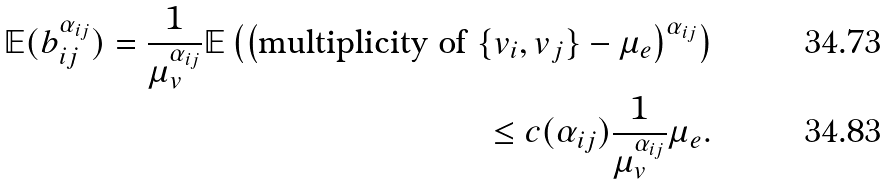Convert formula to latex. <formula><loc_0><loc_0><loc_500><loc_500>\mathbb { E } ( b _ { i j } ^ { \alpha _ { i j } } ) = \frac { 1 } { \mu _ { v } ^ { \alpha _ { i j } } } \mathbb { E } \left ( \left ( \text {multiplicity of } \{ v _ { i } , v _ { j } \} - \mu _ { e } \right ) ^ { \alpha _ { i j } } \right ) \\ \leq c ( \alpha _ { i j } ) \frac { 1 } { \mu _ { v } ^ { \alpha _ { i j } } } \mu _ { e } .</formula> 